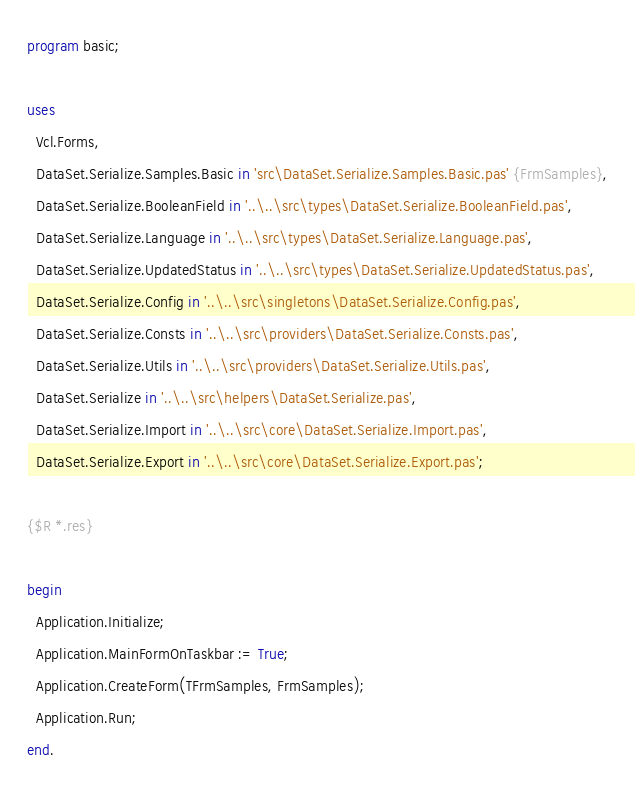<code> <loc_0><loc_0><loc_500><loc_500><_Pascal_>program basic;

uses
  Vcl.Forms,
  DataSet.Serialize.Samples.Basic in 'src\DataSet.Serialize.Samples.Basic.pas' {FrmSamples},
  DataSet.Serialize.BooleanField in '..\..\src\types\DataSet.Serialize.BooleanField.pas',
  DataSet.Serialize.Language in '..\..\src\types\DataSet.Serialize.Language.pas',
  DataSet.Serialize.UpdatedStatus in '..\..\src\types\DataSet.Serialize.UpdatedStatus.pas',
  DataSet.Serialize.Config in '..\..\src\singletons\DataSet.Serialize.Config.pas',
  DataSet.Serialize.Consts in '..\..\src\providers\DataSet.Serialize.Consts.pas',
  DataSet.Serialize.Utils in '..\..\src\providers\DataSet.Serialize.Utils.pas',
  DataSet.Serialize in '..\..\src\helpers\DataSet.Serialize.pas',
  DataSet.Serialize.Import in '..\..\src\core\DataSet.Serialize.Import.pas',
  DataSet.Serialize.Export in '..\..\src\core\DataSet.Serialize.Export.pas';

{$R *.res}

begin
  Application.Initialize;
  Application.MainFormOnTaskbar := True;
  Application.CreateForm(TFrmSamples, FrmSamples);
  Application.Run;
end.
</code> 